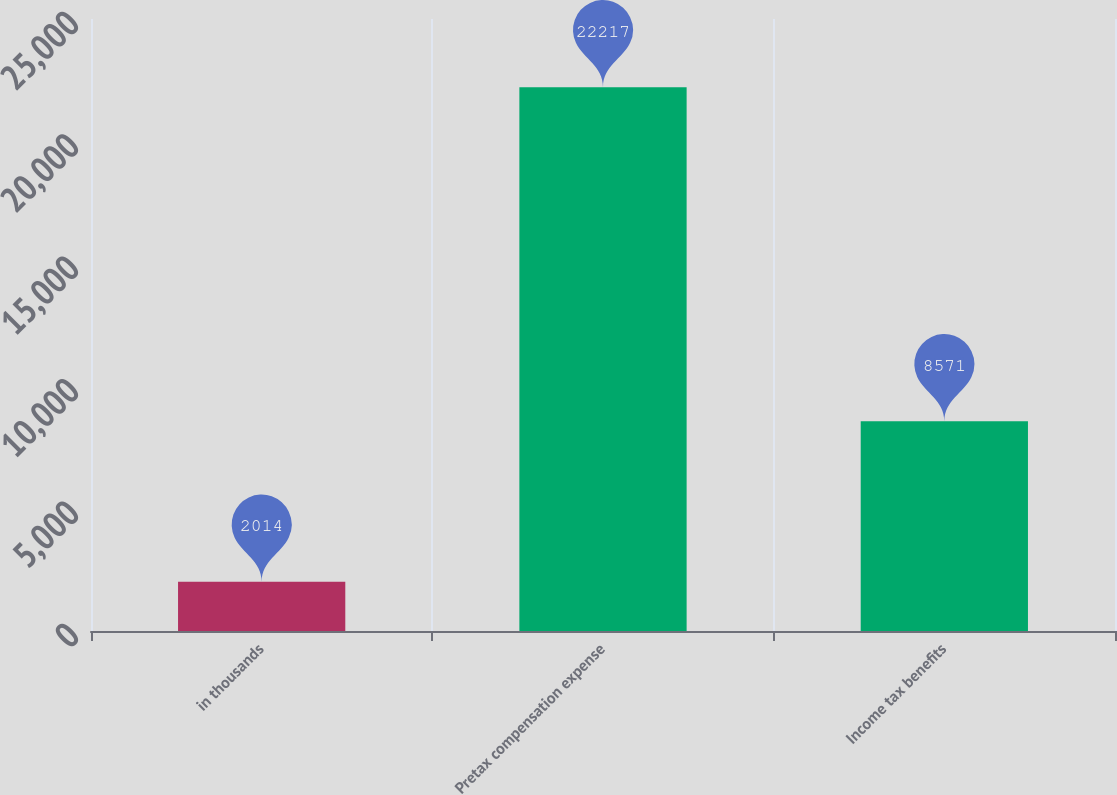Convert chart. <chart><loc_0><loc_0><loc_500><loc_500><bar_chart><fcel>in thousands<fcel>Pretax compensation expense<fcel>Income tax benefits<nl><fcel>2014<fcel>22217<fcel>8571<nl></chart> 